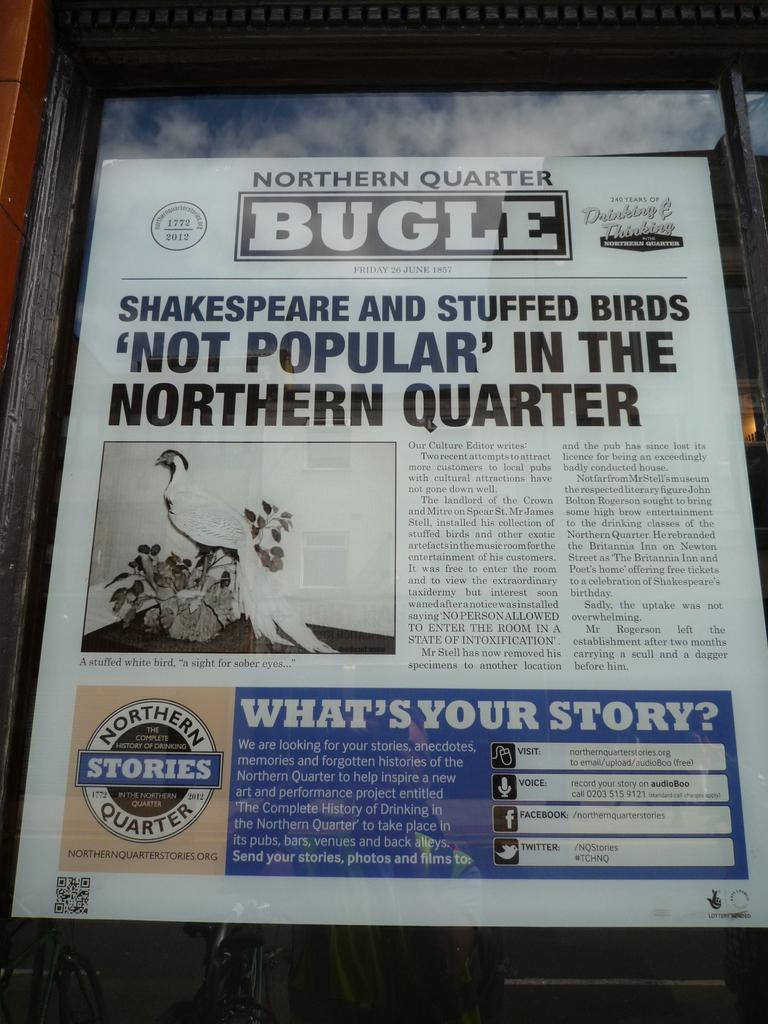<image>
Give a short and clear explanation of the subsequent image. a paper that says 'northern quarter bugle' on it 